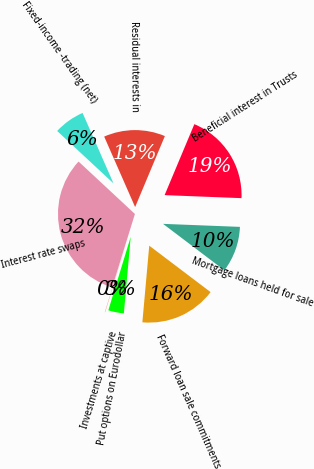<chart> <loc_0><loc_0><loc_500><loc_500><pie_chart><fcel>Mortgage loans held for sale<fcel>Beneficial interest in Trusts<fcel>Residual interests in<fcel>Fixed-income -trading (net)<fcel>Interest rate swaps<fcel>Investments at captive<fcel>Put options on Eurodollar<fcel>Forward loan sale commitments<nl><fcel>9.69%<fcel>19.31%<fcel>12.9%<fcel>6.49%<fcel>32.14%<fcel>0.08%<fcel>3.28%<fcel>16.11%<nl></chart> 